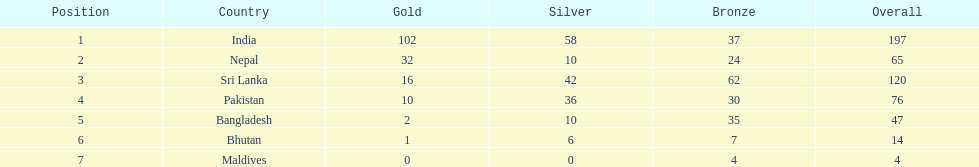Can you parse all the data within this table? {'header': ['Position', 'Country', 'Gold', 'Silver', 'Bronze', 'Overall'], 'rows': [['1', 'India', '102', '58', '37', '197'], ['2', 'Nepal', '32', '10', '24', '65'], ['3', 'Sri Lanka', '16', '42', '62', '120'], ['4', 'Pakistan', '10', '36', '30', '76'], ['5', 'Bangladesh', '2', '10', '35', '47'], ['6', 'Bhutan', '1', '6', '7', '14'], ['7', 'Maldives', '0', '0', '4', '4']]} Name a country listed in the table, other than india? Nepal. 